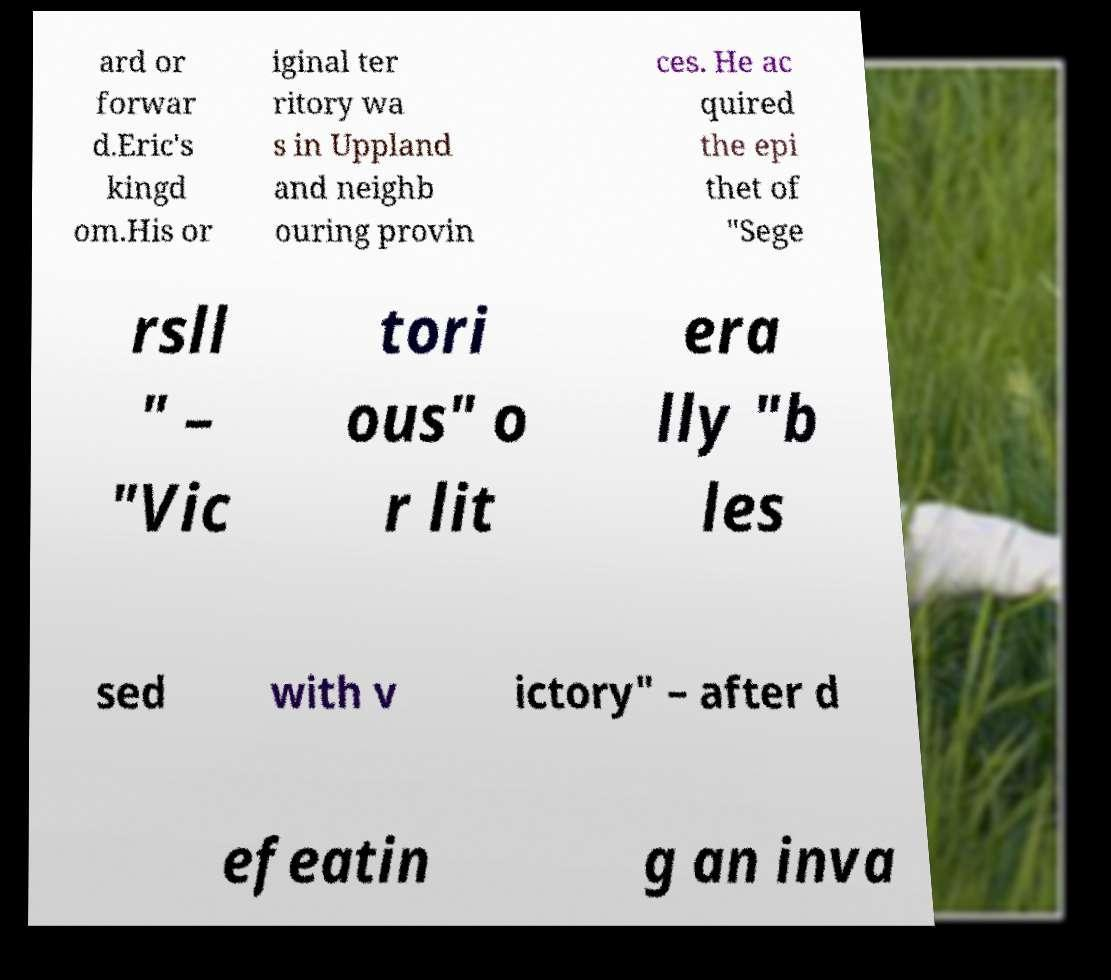Can you accurately transcribe the text from the provided image for me? ard or forwar d.Eric's kingd om.His or iginal ter ritory wa s in Uppland and neighb ouring provin ces. He ac quired the epi thet of "Sege rsll " – "Vic tori ous" o r lit era lly "b les sed with v ictory" – after d efeatin g an inva 